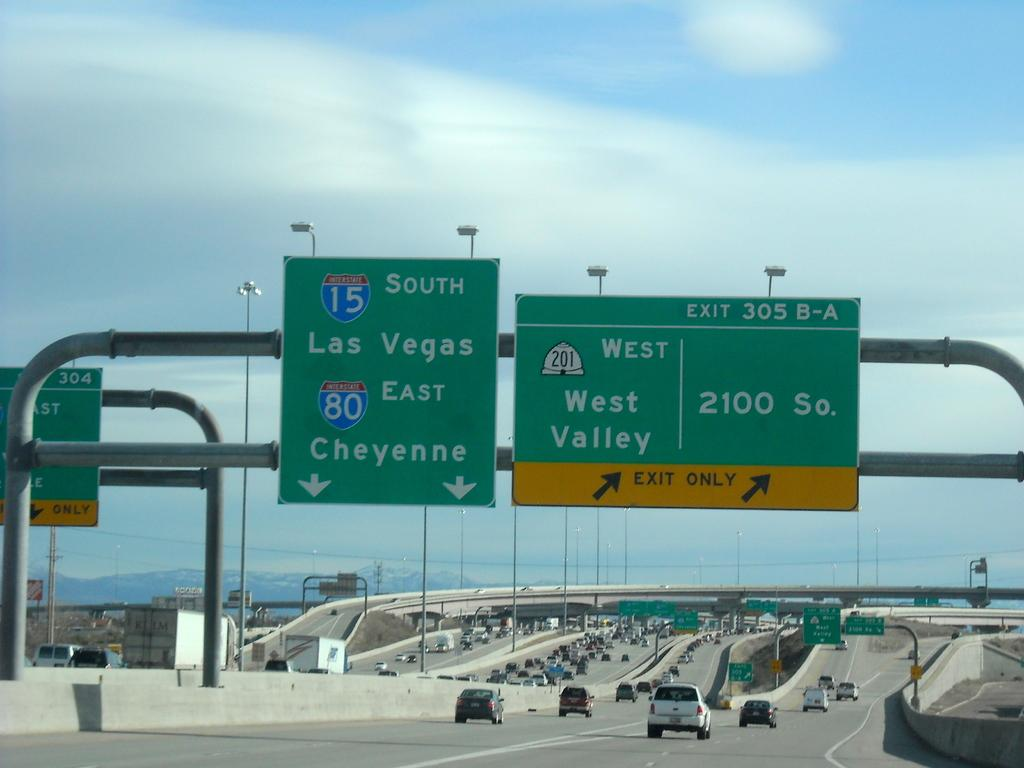<image>
Write a terse but informative summary of the picture. A green sign with lanes that go to 15 South Las Vegas and 80 East Cheyenne. 